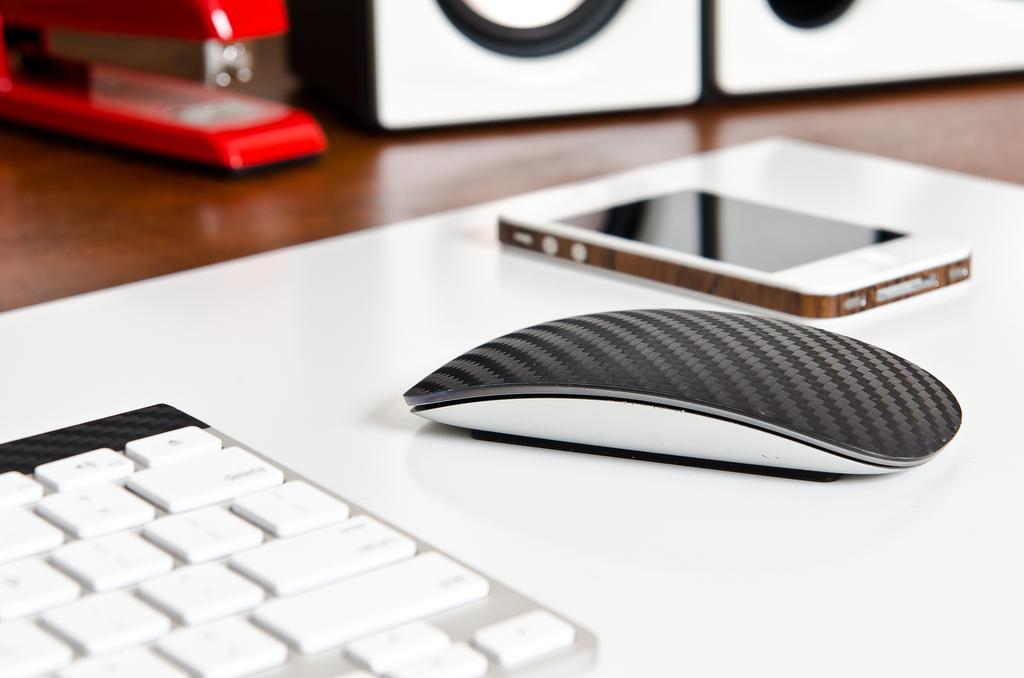What type of device is present in the image? There is a mobile in the image. What small animal can be seen in the image? There is a mouse in the image. What is used for typing in the image? There is a keyboard in the image. What is used for amplifying sound in the image? There are speakers in the image. What is used for fastening papers in the image? There is a stapler in the image. Where are all these objects located in the image? All these objects are placed on a platform. What type of ink is used by the mouse in the image? There is no mouse using ink in the image; it is a small animal. What company is responsible for manufacturing the mobile in the image? The image does not provide information about the manufacturer of the mobile. 